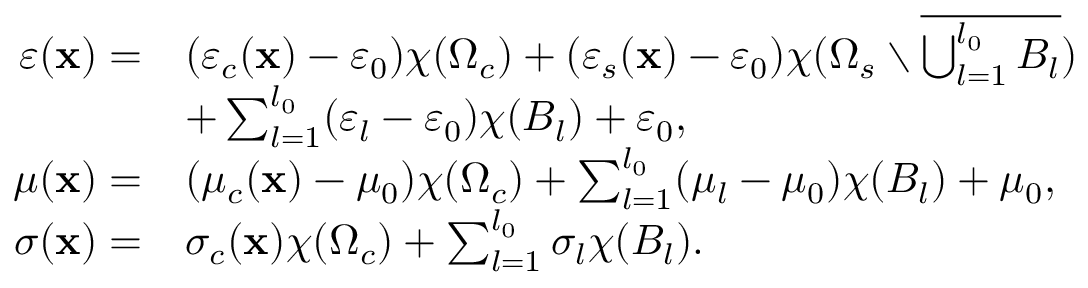Convert formula to latex. <formula><loc_0><loc_0><loc_500><loc_500>\begin{array} { r l } { \varepsilon ( x ) = } & { ( \varepsilon _ { c } ( x ) - \varepsilon _ { 0 } ) \chi ( \Omega _ { c } ) + ( \varepsilon _ { s } ( x ) - \varepsilon _ { 0 } ) \chi ( \Omega _ { s } \ \overline { { \bigcup _ { l = 1 } ^ { l _ { 0 } } B _ { l } } } ) } \\ & { + \sum _ { l = 1 } ^ { l _ { 0 } } ( \varepsilon _ { l } - \varepsilon _ { 0 } ) \chi ( B _ { l } ) + \varepsilon _ { 0 } , } \\ { \quad \mu ( x ) = } & { ( \mu _ { c } ( x ) - \mu _ { 0 } ) \chi ( \Omega _ { c } ) + \sum _ { l = 1 } ^ { l _ { 0 } } ( \mu _ { l } - \mu _ { 0 } ) \chi ( B _ { l } ) + \mu _ { 0 } , } \\ { \sigma ( x ) = } & { \sigma _ { c } ( x ) \chi ( \Omega _ { c } ) + \sum _ { l = 1 } ^ { l _ { 0 } } \sigma _ { l } \chi ( B _ { l } ) . } \end{array}</formula> 